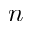<formula> <loc_0><loc_0><loc_500><loc_500>n</formula> 